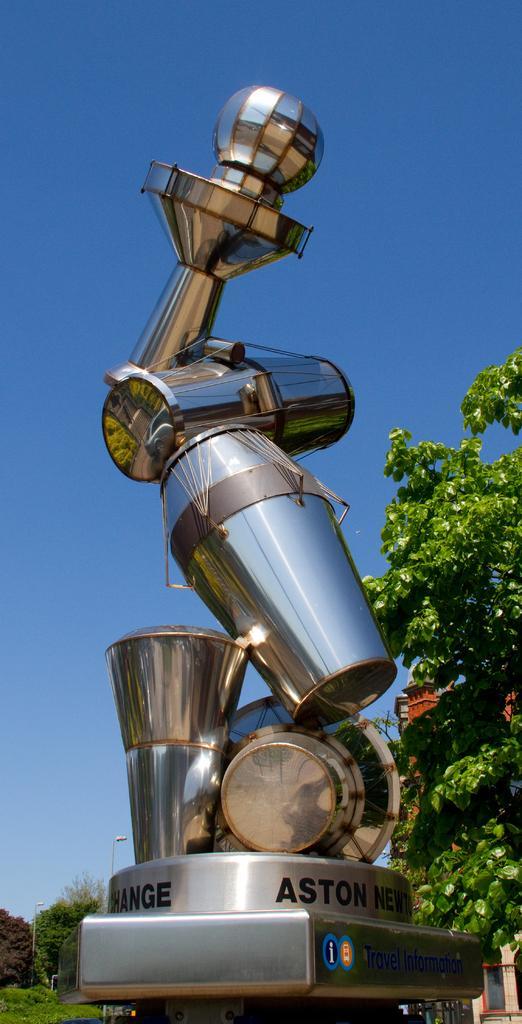Could you give a brief overview of what you see in this image? In the image there is a metal statue in the middle with trees behind it all over the place and above its sky. 